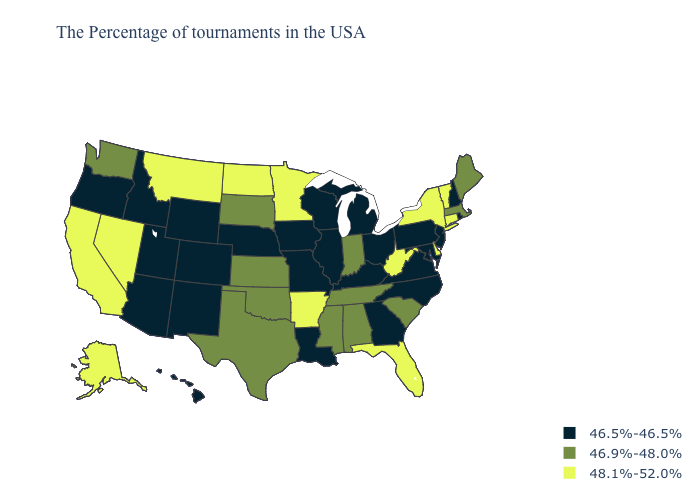What is the highest value in the USA?
Answer briefly. 48.1%-52.0%. Name the states that have a value in the range 46.5%-46.5%?
Quick response, please. Rhode Island, New Hampshire, New Jersey, Maryland, Pennsylvania, Virginia, North Carolina, Ohio, Georgia, Michigan, Kentucky, Wisconsin, Illinois, Louisiana, Missouri, Iowa, Nebraska, Wyoming, Colorado, New Mexico, Utah, Arizona, Idaho, Oregon, Hawaii. Which states have the highest value in the USA?
Be succinct. Vermont, Connecticut, New York, Delaware, West Virginia, Florida, Arkansas, Minnesota, North Dakota, Montana, Nevada, California, Alaska. What is the lowest value in the South?
Concise answer only. 46.5%-46.5%. What is the lowest value in the West?
Write a very short answer. 46.5%-46.5%. What is the value of Tennessee?
Write a very short answer. 46.9%-48.0%. What is the value of Nevada?
Keep it brief. 48.1%-52.0%. Among the states that border Wyoming , which have the lowest value?
Be succinct. Nebraska, Colorado, Utah, Idaho. Is the legend a continuous bar?
Give a very brief answer. No. What is the value of Wyoming?
Concise answer only. 46.5%-46.5%. Name the states that have a value in the range 46.5%-46.5%?
Be succinct. Rhode Island, New Hampshire, New Jersey, Maryland, Pennsylvania, Virginia, North Carolina, Ohio, Georgia, Michigan, Kentucky, Wisconsin, Illinois, Louisiana, Missouri, Iowa, Nebraska, Wyoming, Colorado, New Mexico, Utah, Arizona, Idaho, Oregon, Hawaii. Which states have the highest value in the USA?
Answer briefly. Vermont, Connecticut, New York, Delaware, West Virginia, Florida, Arkansas, Minnesota, North Dakota, Montana, Nevada, California, Alaska. Name the states that have a value in the range 46.5%-46.5%?
Give a very brief answer. Rhode Island, New Hampshire, New Jersey, Maryland, Pennsylvania, Virginia, North Carolina, Ohio, Georgia, Michigan, Kentucky, Wisconsin, Illinois, Louisiana, Missouri, Iowa, Nebraska, Wyoming, Colorado, New Mexico, Utah, Arizona, Idaho, Oregon, Hawaii. What is the value of Washington?
Give a very brief answer. 46.9%-48.0%. What is the value of Iowa?
Short answer required. 46.5%-46.5%. 